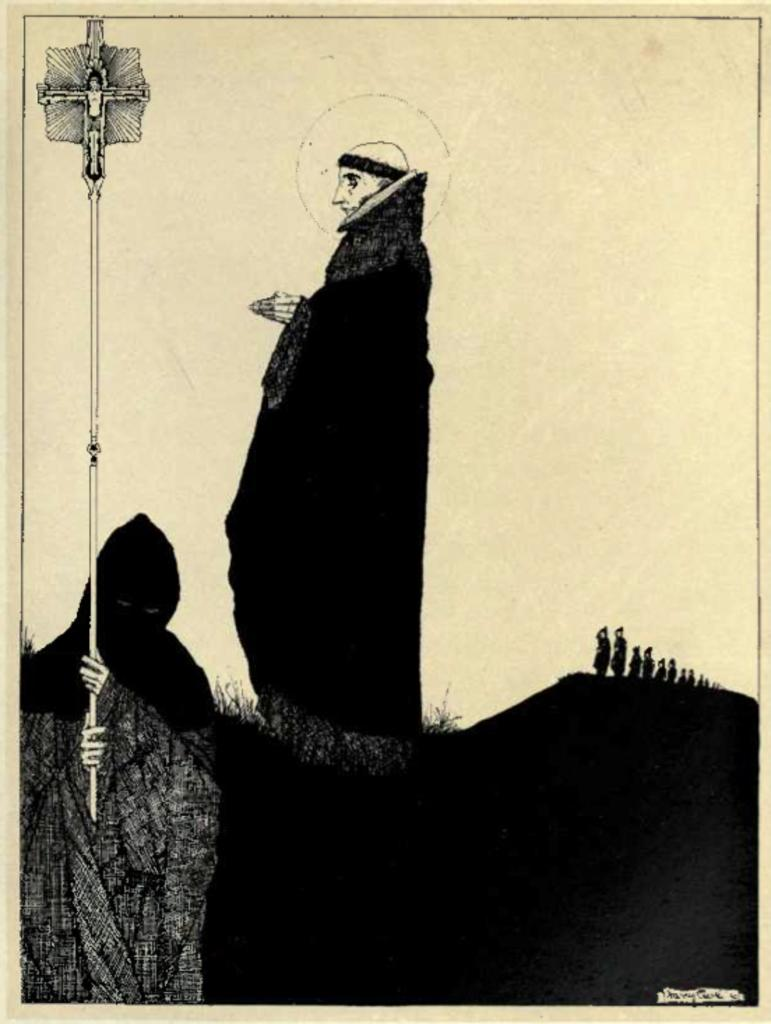What type of image is being described? The image is an illustration. What can be seen in the illustration? There are pictures of persons in the image. What religious symbol is present in the illustration? There is a cross symbol in the image. How is the cross symbol displayed in the illustration? The cross symbol is on a pole. What type of sponge can be seen floating in the water near the persons in the image? There is no sponge or water present in the image; it is an illustration featuring pictures of persons and a cross symbol on a pole. What kind of apparatus is being used by the persons in the image? The provided facts do not mention any apparatus being used by the persons in the image. 